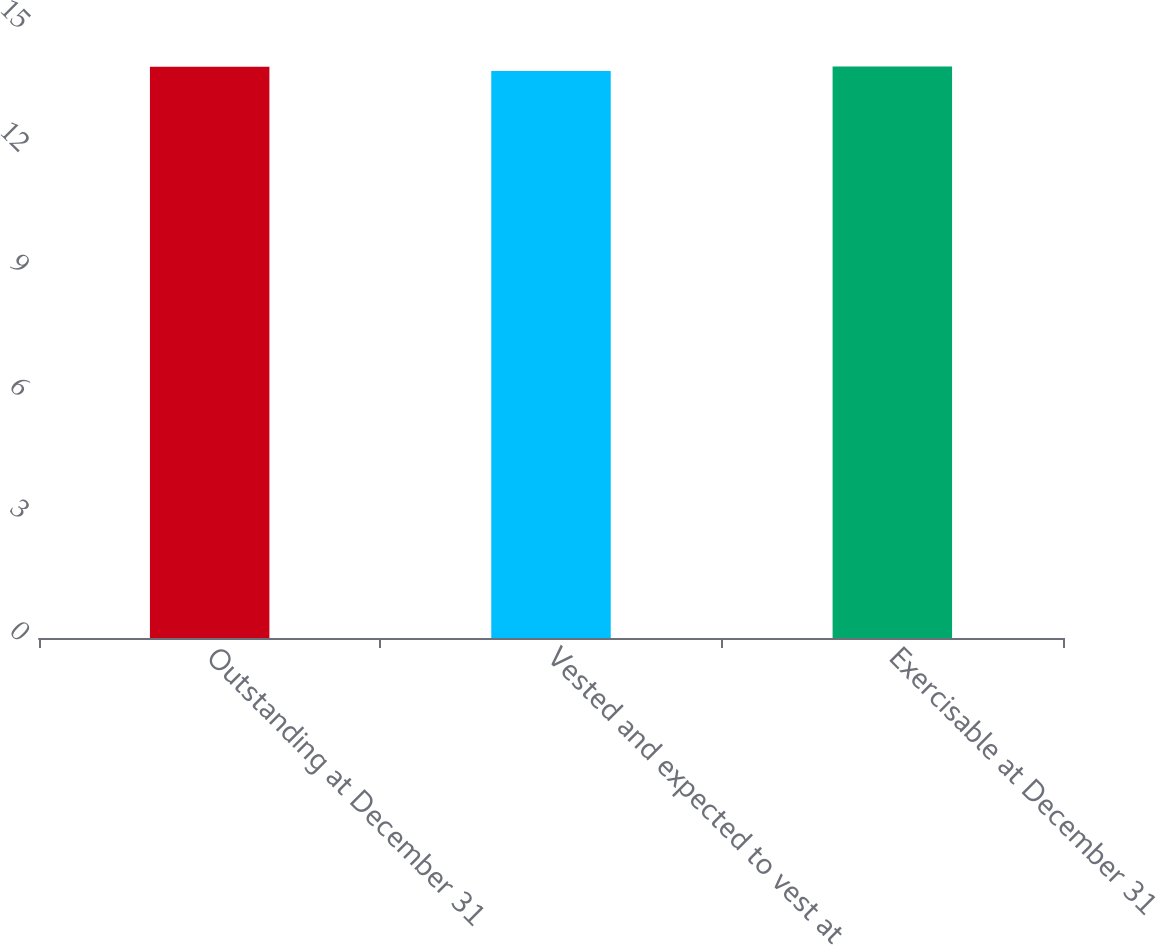Convert chart to OTSL. <chart><loc_0><loc_0><loc_500><loc_500><bar_chart><fcel>Outstanding at December 31<fcel>Vested and expected to vest at<fcel>Exercisable at December 31<nl><fcel>14<fcel>13.9<fcel>14.01<nl></chart> 